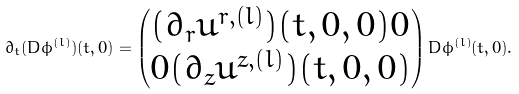<formula> <loc_0><loc_0><loc_500><loc_500>\partial _ { t } ( D \phi ^ { ( l ) } ) ( t , 0 ) = \begin{pmatrix} ( \partial _ { r } u ^ { r , ( l ) } ) ( t , 0 , 0 ) 0 \\ 0 ( \partial _ { z } u ^ { z , ( l ) } ) ( t , 0 , 0 ) \end{pmatrix} D \phi ^ { ( l ) } ( t , 0 ) .</formula> 